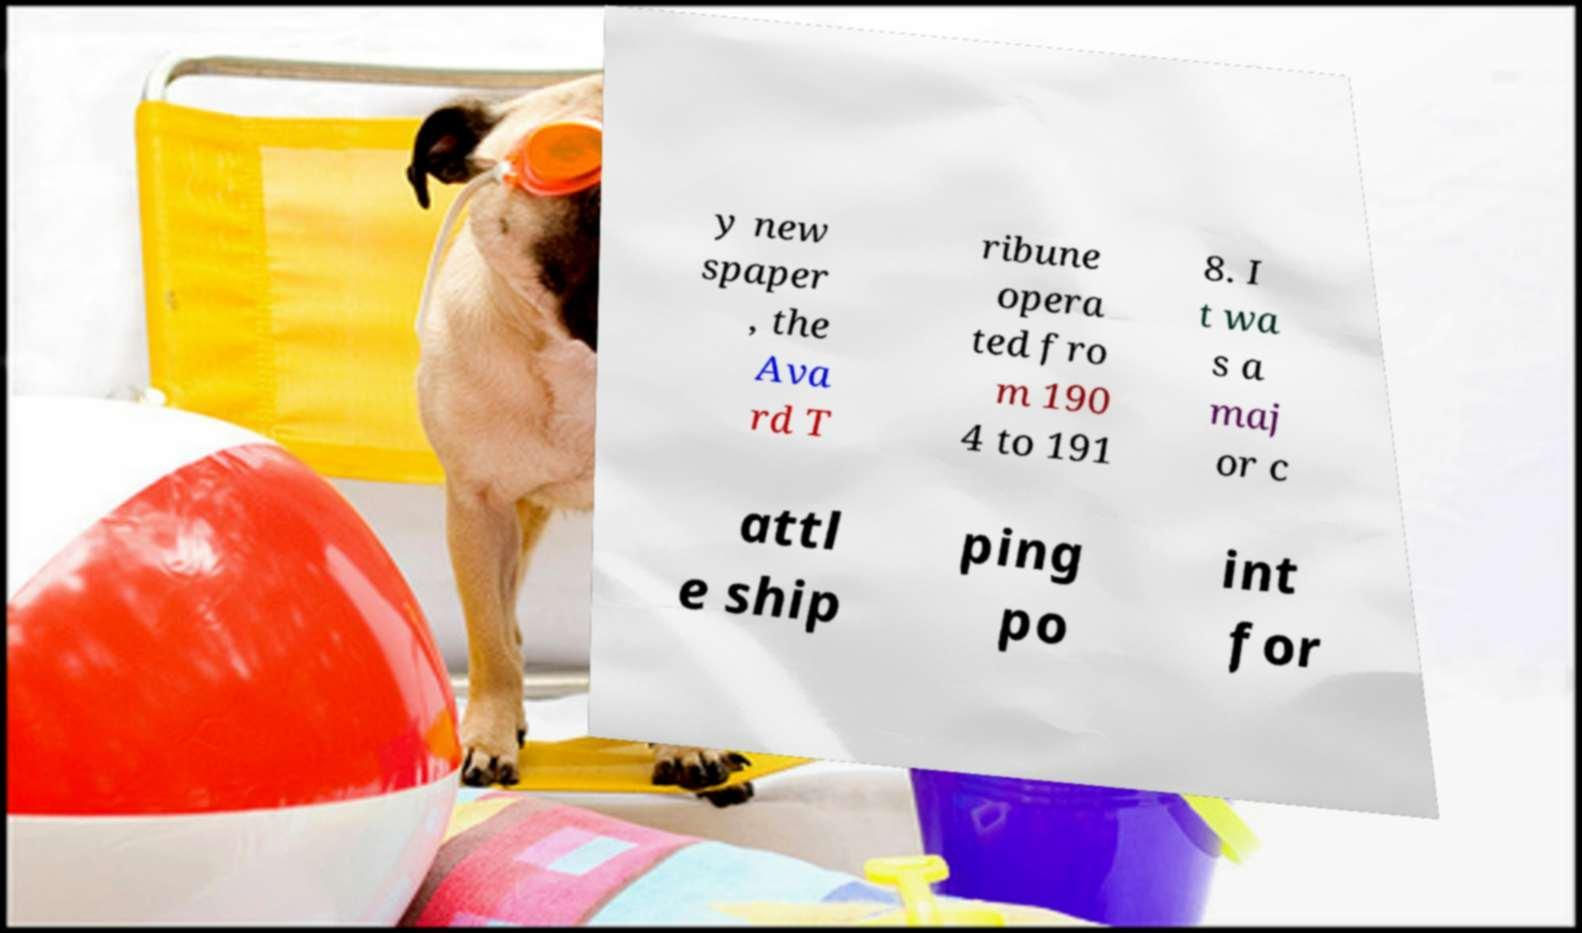Please identify and transcribe the text found in this image. y new spaper , the Ava rd T ribune opera ted fro m 190 4 to 191 8. I t wa s a maj or c attl e ship ping po int for 